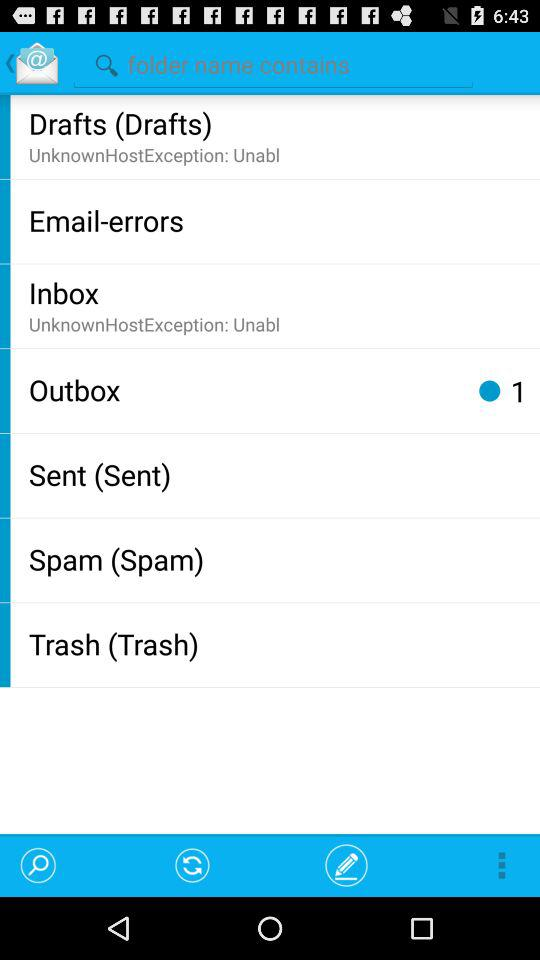How many unread emails are there?
Answer the question using a single word or phrase. 1 